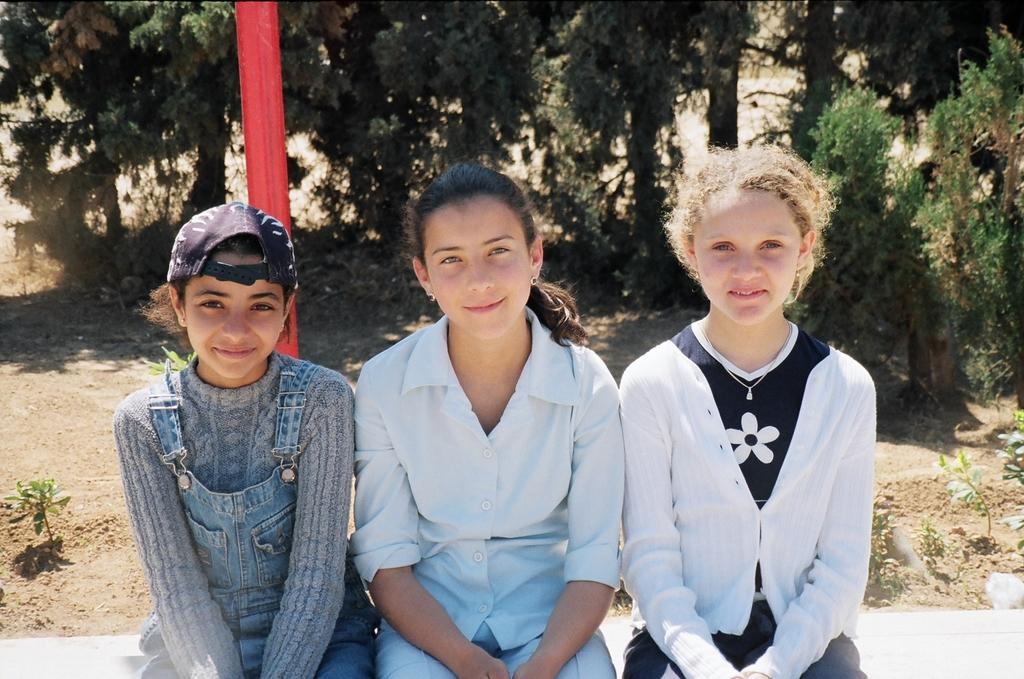How many girls are sitting in the image? There are 3 girls sitting in the image. Can you describe the clothing of one of the girls? One of the girls is wearing a cap. What can be seen in the background of the image? There are trees and plants in the background of the image. What type of needle is being used by one of the girls in the image? There is no needle present in the image. What kind of shoes are the girls wearing in the image? The provided facts do not mention shoes, so we cannot determine what kind of shoes the girls are wearing. 